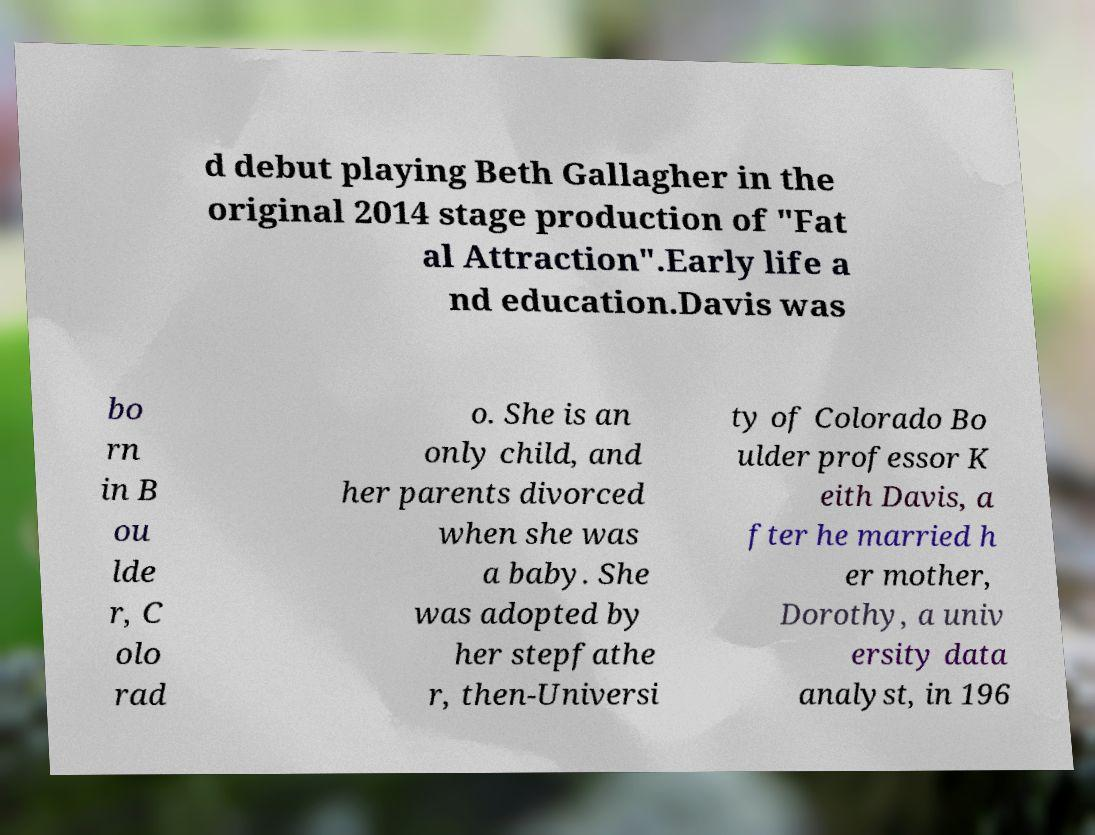Could you extract and type out the text from this image? d debut playing Beth Gallagher in the original 2014 stage production of "Fat al Attraction".Early life a nd education.Davis was bo rn in B ou lde r, C olo rad o. She is an only child, and her parents divorced when she was a baby. She was adopted by her stepfathe r, then-Universi ty of Colorado Bo ulder professor K eith Davis, a fter he married h er mother, Dorothy, a univ ersity data analyst, in 196 